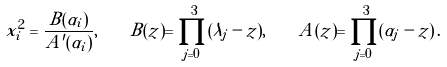<formula> <loc_0><loc_0><loc_500><loc_500>x _ { i } ^ { 2 } = \frac { B ( \alpha _ { i } ) } { A ^ { \prime } ( \alpha _ { i } ) } , \quad B ( z ) = \prod _ { j = 0 } ^ { 3 } ( \lambda _ { j } - z ) , \quad A ( z ) = \prod _ { j = 0 } ^ { 3 } ( \alpha _ { j } - z ) \, .</formula> 